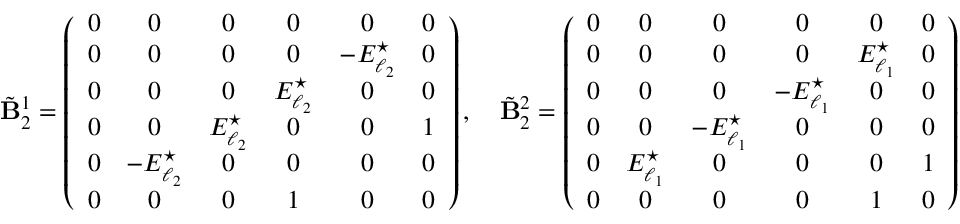Convert formula to latex. <formula><loc_0><loc_0><loc_500><loc_500>\tilde { B } _ { 2 } ^ { 1 } = \left ( \begin{array} { c c c c c c } { 0 } & { 0 } & { 0 } & { 0 } & { 0 } & { 0 } \\ { 0 } & { 0 } & { 0 } & { 0 } & { - E _ { \ell _ { 2 } } ^ { ^ { * } } } & { 0 } \\ { 0 } & { 0 } & { 0 } & { E _ { \ell _ { 2 } } ^ { ^ { * } } } & { 0 } & { 0 } \\ { 0 } & { 0 } & { E _ { \ell _ { 2 } } ^ { ^ { * } } } & { 0 } & { 0 } & { 1 } \\ { 0 } & { - E _ { \ell _ { 2 } } ^ { ^ { * } } } & { 0 } & { 0 } & { 0 } & { 0 } \\ { 0 } & { 0 } & { 0 } & { 1 } & { 0 } & { 0 } \end{array} \right ) , \quad \tilde { B } _ { 2 } ^ { 2 } = \left ( \begin{array} { c c c c c c } { 0 } & { 0 } & { 0 } & { 0 } & { 0 } & { 0 } \\ { 0 } & { 0 } & { 0 } & { 0 } & { E _ { \ell _ { 1 } } ^ { ^ { * } } } & { 0 } \\ { 0 } & { 0 } & { 0 } & { - E _ { \ell _ { 1 } } ^ { ^ { * } } } & { 0 } & { 0 } \\ { 0 } & { 0 } & { - E _ { \ell _ { 1 } } ^ { ^ { * } } } & { 0 } & { 0 } & { 0 } \\ { 0 } & { E _ { \ell _ { 1 } } ^ { ^ { * } } } & { 0 } & { 0 } & { 0 } & { 1 } \\ { 0 } & { 0 } & { 0 } & { 0 } & { 1 } & { 0 } \end{array} \right )</formula> 